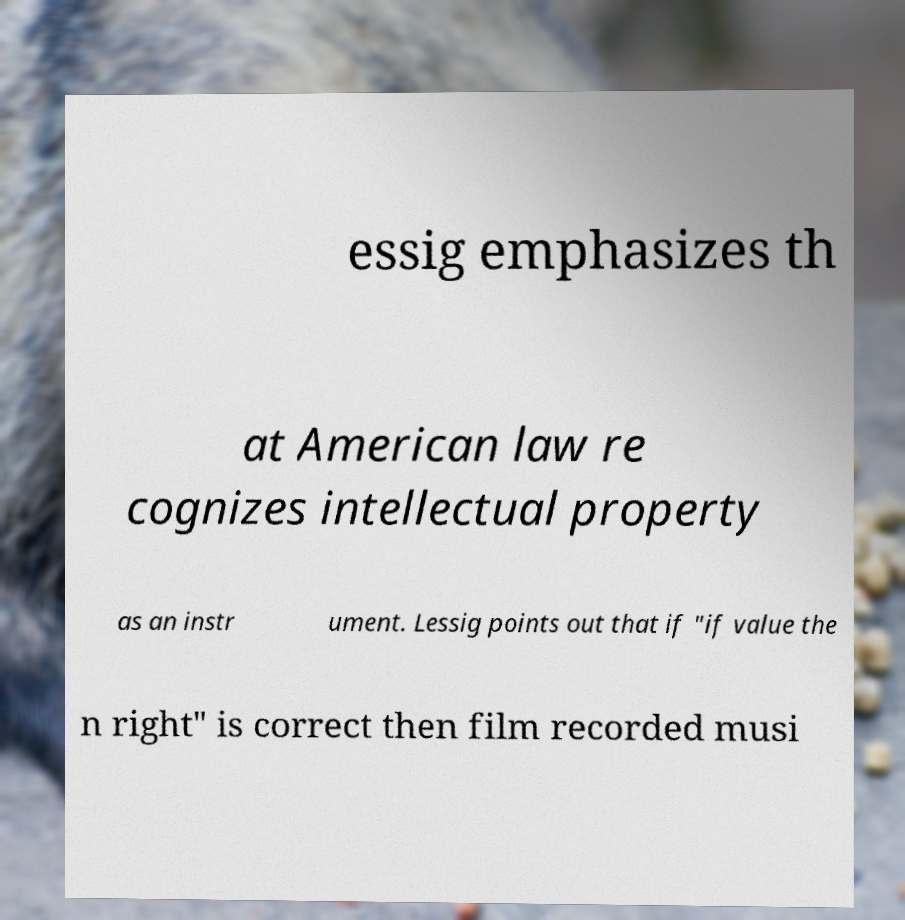Can you read and provide the text displayed in the image?This photo seems to have some interesting text. Can you extract and type it out for me? essig emphasizes th at American law re cognizes intellectual property as an instr ument. Lessig points out that if "if value the n right" is correct then film recorded musi 